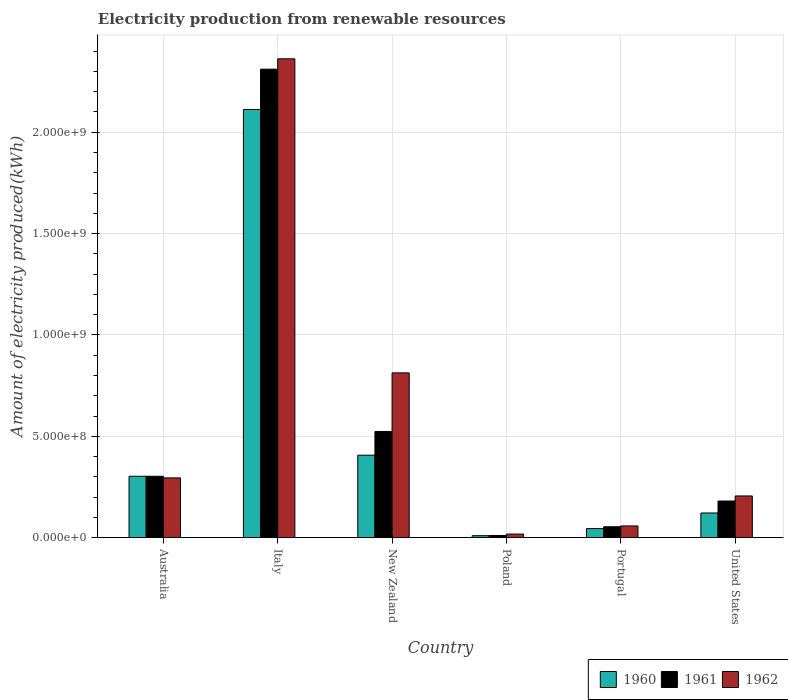How many different coloured bars are there?
Offer a terse response. 3. Are the number of bars on each tick of the X-axis equal?
Provide a succinct answer. Yes. How many bars are there on the 5th tick from the right?
Offer a very short reply. 3. What is the label of the 6th group of bars from the left?
Give a very brief answer. United States. In how many cases, is the number of bars for a given country not equal to the number of legend labels?
Ensure brevity in your answer.  0. What is the amount of electricity produced in 1960 in New Zealand?
Your answer should be very brief. 4.07e+08. Across all countries, what is the maximum amount of electricity produced in 1961?
Offer a very short reply. 2.31e+09. Across all countries, what is the minimum amount of electricity produced in 1962?
Keep it short and to the point. 1.80e+07. What is the total amount of electricity produced in 1962 in the graph?
Provide a short and direct response. 3.75e+09. What is the difference between the amount of electricity produced in 1962 in Italy and that in United States?
Ensure brevity in your answer.  2.16e+09. What is the difference between the amount of electricity produced in 1962 in Portugal and the amount of electricity produced in 1960 in Poland?
Your answer should be compact. 4.80e+07. What is the average amount of electricity produced in 1962 per country?
Provide a short and direct response. 6.25e+08. What is the difference between the amount of electricity produced of/in 1961 and amount of electricity produced of/in 1962 in New Zealand?
Offer a very short reply. -2.89e+08. What is the ratio of the amount of electricity produced in 1960 in Italy to that in Poland?
Provide a short and direct response. 211.2. Is the difference between the amount of electricity produced in 1961 in New Zealand and Portugal greater than the difference between the amount of electricity produced in 1962 in New Zealand and Portugal?
Ensure brevity in your answer.  No. What is the difference between the highest and the second highest amount of electricity produced in 1960?
Your answer should be very brief. 1.81e+09. What is the difference between the highest and the lowest amount of electricity produced in 1961?
Ensure brevity in your answer.  2.30e+09. In how many countries, is the amount of electricity produced in 1962 greater than the average amount of electricity produced in 1962 taken over all countries?
Keep it short and to the point. 2. Is the sum of the amount of electricity produced in 1962 in Australia and United States greater than the maximum amount of electricity produced in 1960 across all countries?
Provide a succinct answer. No. What does the 3rd bar from the left in United States represents?
Give a very brief answer. 1962. Are all the bars in the graph horizontal?
Your answer should be very brief. No. What is the difference between two consecutive major ticks on the Y-axis?
Your answer should be very brief. 5.00e+08. Are the values on the major ticks of Y-axis written in scientific E-notation?
Your answer should be compact. Yes. How many legend labels are there?
Your answer should be compact. 3. What is the title of the graph?
Give a very brief answer. Electricity production from renewable resources. What is the label or title of the X-axis?
Offer a very short reply. Country. What is the label or title of the Y-axis?
Keep it short and to the point. Amount of electricity produced(kWh). What is the Amount of electricity produced(kWh) of 1960 in Australia?
Your response must be concise. 3.03e+08. What is the Amount of electricity produced(kWh) in 1961 in Australia?
Give a very brief answer. 3.03e+08. What is the Amount of electricity produced(kWh) of 1962 in Australia?
Your answer should be very brief. 2.95e+08. What is the Amount of electricity produced(kWh) of 1960 in Italy?
Offer a terse response. 2.11e+09. What is the Amount of electricity produced(kWh) of 1961 in Italy?
Your answer should be compact. 2.31e+09. What is the Amount of electricity produced(kWh) of 1962 in Italy?
Your answer should be very brief. 2.36e+09. What is the Amount of electricity produced(kWh) of 1960 in New Zealand?
Your answer should be compact. 4.07e+08. What is the Amount of electricity produced(kWh) of 1961 in New Zealand?
Provide a succinct answer. 5.24e+08. What is the Amount of electricity produced(kWh) of 1962 in New Zealand?
Provide a succinct answer. 8.13e+08. What is the Amount of electricity produced(kWh) of 1961 in Poland?
Offer a very short reply. 1.10e+07. What is the Amount of electricity produced(kWh) in 1962 in Poland?
Give a very brief answer. 1.80e+07. What is the Amount of electricity produced(kWh) in 1960 in Portugal?
Make the answer very short. 4.50e+07. What is the Amount of electricity produced(kWh) of 1961 in Portugal?
Ensure brevity in your answer.  5.40e+07. What is the Amount of electricity produced(kWh) of 1962 in Portugal?
Keep it short and to the point. 5.80e+07. What is the Amount of electricity produced(kWh) of 1960 in United States?
Your answer should be very brief. 1.22e+08. What is the Amount of electricity produced(kWh) of 1961 in United States?
Ensure brevity in your answer.  1.81e+08. What is the Amount of electricity produced(kWh) of 1962 in United States?
Offer a very short reply. 2.06e+08. Across all countries, what is the maximum Amount of electricity produced(kWh) of 1960?
Ensure brevity in your answer.  2.11e+09. Across all countries, what is the maximum Amount of electricity produced(kWh) in 1961?
Make the answer very short. 2.31e+09. Across all countries, what is the maximum Amount of electricity produced(kWh) in 1962?
Offer a very short reply. 2.36e+09. Across all countries, what is the minimum Amount of electricity produced(kWh) in 1961?
Make the answer very short. 1.10e+07. Across all countries, what is the minimum Amount of electricity produced(kWh) in 1962?
Keep it short and to the point. 1.80e+07. What is the total Amount of electricity produced(kWh) of 1960 in the graph?
Offer a terse response. 3.00e+09. What is the total Amount of electricity produced(kWh) of 1961 in the graph?
Give a very brief answer. 3.38e+09. What is the total Amount of electricity produced(kWh) of 1962 in the graph?
Make the answer very short. 3.75e+09. What is the difference between the Amount of electricity produced(kWh) of 1960 in Australia and that in Italy?
Make the answer very short. -1.81e+09. What is the difference between the Amount of electricity produced(kWh) in 1961 in Australia and that in Italy?
Give a very brief answer. -2.01e+09. What is the difference between the Amount of electricity produced(kWh) of 1962 in Australia and that in Italy?
Make the answer very short. -2.07e+09. What is the difference between the Amount of electricity produced(kWh) in 1960 in Australia and that in New Zealand?
Make the answer very short. -1.04e+08. What is the difference between the Amount of electricity produced(kWh) in 1961 in Australia and that in New Zealand?
Keep it short and to the point. -2.21e+08. What is the difference between the Amount of electricity produced(kWh) of 1962 in Australia and that in New Zealand?
Your answer should be very brief. -5.18e+08. What is the difference between the Amount of electricity produced(kWh) in 1960 in Australia and that in Poland?
Offer a very short reply. 2.93e+08. What is the difference between the Amount of electricity produced(kWh) of 1961 in Australia and that in Poland?
Keep it short and to the point. 2.92e+08. What is the difference between the Amount of electricity produced(kWh) of 1962 in Australia and that in Poland?
Give a very brief answer. 2.77e+08. What is the difference between the Amount of electricity produced(kWh) in 1960 in Australia and that in Portugal?
Provide a short and direct response. 2.58e+08. What is the difference between the Amount of electricity produced(kWh) in 1961 in Australia and that in Portugal?
Your response must be concise. 2.49e+08. What is the difference between the Amount of electricity produced(kWh) in 1962 in Australia and that in Portugal?
Keep it short and to the point. 2.37e+08. What is the difference between the Amount of electricity produced(kWh) in 1960 in Australia and that in United States?
Give a very brief answer. 1.81e+08. What is the difference between the Amount of electricity produced(kWh) in 1961 in Australia and that in United States?
Offer a very short reply. 1.22e+08. What is the difference between the Amount of electricity produced(kWh) in 1962 in Australia and that in United States?
Ensure brevity in your answer.  8.90e+07. What is the difference between the Amount of electricity produced(kWh) in 1960 in Italy and that in New Zealand?
Offer a very short reply. 1.70e+09. What is the difference between the Amount of electricity produced(kWh) of 1961 in Italy and that in New Zealand?
Provide a short and direct response. 1.79e+09. What is the difference between the Amount of electricity produced(kWh) of 1962 in Italy and that in New Zealand?
Provide a succinct answer. 1.55e+09. What is the difference between the Amount of electricity produced(kWh) in 1960 in Italy and that in Poland?
Make the answer very short. 2.10e+09. What is the difference between the Amount of electricity produced(kWh) of 1961 in Italy and that in Poland?
Offer a terse response. 2.30e+09. What is the difference between the Amount of electricity produced(kWh) of 1962 in Italy and that in Poland?
Offer a terse response. 2.34e+09. What is the difference between the Amount of electricity produced(kWh) of 1960 in Italy and that in Portugal?
Offer a terse response. 2.07e+09. What is the difference between the Amount of electricity produced(kWh) of 1961 in Italy and that in Portugal?
Your answer should be compact. 2.26e+09. What is the difference between the Amount of electricity produced(kWh) of 1962 in Italy and that in Portugal?
Your response must be concise. 2.30e+09. What is the difference between the Amount of electricity produced(kWh) of 1960 in Italy and that in United States?
Keep it short and to the point. 1.99e+09. What is the difference between the Amount of electricity produced(kWh) in 1961 in Italy and that in United States?
Ensure brevity in your answer.  2.13e+09. What is the difference between the Amount of electricity produced(kWh) in 1962 in Italy and that in United States?
Your answer should be compact. 2.16e+09. What is the difference between the Amount of electricity produced(kWh) of 1960 in New Zealand and that in Poland?
Your answer should be very brief. 3.97e+08. What is the difference between the Amount of electricity produced(kWh) in 1961 in New Zealand and that in Poland?
Your response must be concise. 5.13e+08. What is the difference between the Amount of electricity produced(kWh) in 1962 in New Zealand and that in Poland?
Ensure brevity in your answer.  7.95e+08. What is the difference between the Amount of electricity produced(kWh) of 1960 in New Zealand and that in Portugal?
Offer a terse response. 3.62e+08. What is the difference between the Amount of electricity produced(kWh) of 1961 in New Zealand and that in Portugal?
Give a very brief answer. 4.70e+08. What is the difference between the Amount of electricity produced(kWh) of 1962 in New Zealand and that in Portugal?
Ensure brevity in your answer.  7.55e+08. What is the difference between the Amount of electricity produced(kWh) in 1960 in New Zealand and that in United States?
Provide a succinct answer. 2.85e+08. What is the difference between the Amount of electricity produced(kWh) of 1961 in New Zealand and that in United States?
Ensure brevity in your answer.  3.43e+08. What is the difference between the Amount of electricity produced(kWh) in 1962 in New Zealand and that in United States?
Offer a terse response. 6.07e+08. What is the difference between the Amount of electricity produced(kWh) in 1960 in Poland and that in Portugal?
Ensure brevity in your answer.  -3.50e+07. What is the difference between the Amount of electricity produced(kWh) in 1961 in Poland and that in Portugal?
Your response must be concise. -4.30e+07. What is the difference between the Amount of electricity produced(kWh) of 1962 in Poland and that in Portugal?
Offer a terse response. -4.00e+07. What is the difference between the Amount of electricity produced(kWh) of 1960 in Poland and that in United States?
Make the answer very short. -1.12e+08. What is the difference between the Amount of electricity produced(kWh) of 1961 in Poland and that in United States?
Give a very brief answer. -1.70e+08. What is the difference between the Amount of electricity produced(kWh) in 1962 in Poland and that in United States?
Make the answer very short. -1.88e+08. What is the difference between the Amount of electricity produced(kWh) of 1960 in Portugal and that in United States?
Your answer should be compact. -7.70e+07. What is the difference between the Amount of electricity produced(kWh) in 1961 in Portugal and that in United States?
Provide a succinct answer. -1.27e+08. What is the difference between the Amount of electricity produced(kWh) of 1962 in Portugal and that in United States?
Your response must be concise. -1.48e+08. What is the difference between the Amount of electricity produced(kWh) of 1960 in Australia and the Amount of electricity produced(kWh) of 1961 in Italy?
Keep it short and to the point. -2.01e+09. What is the difference between the Amount of electricity produced(kWh) of 1960 in Australia and the Amount of electricity produced(kWh) of 1962 in Italy?
Offer a terse response. -2.06e+09. What is the difference between the Amount of electricity produced(kWh) in 1961 in Australia and the Amount of electricity produced(kWh) in 1962 in Italy?
Ensure brevity in your answer.  -2.06e+09. What is the difference between the Amount of electricity produced(kWh) of 1960 in Australia and the Amount of electricity produced(kWh) of 1961 in New Zealand?
Give a very brief answer. -2.21e+08. What is the difference between the Amount of electricity produced(kWh) in 1960 in Australia and the Amount of electricity produced(kWh) in 1962 in New Zealand?
Keep it short and to the point. -5.10e+08. What is the difference between the Amount of electricity produced(kWh) in 1961 in Australia and the Amount of electricity produced(kWh) in 1962 in New Zealand?
Give a very brief answer. -5.10e+08. What is the difference between the Amount of electricity produced(kWh) of 1960 in Australia and the Amount of electricity produced(kWh) of 1961 in Poland?
Give a very brief answer. 2.92e+08. What is the difference between the Amount of electricity produced(kWh) of 1960 in Australia and the Amount of electricity produced(kWh) of 1962 in Poland?
Provide a succinct answer. 2.85e+08. What is the difference between the Amount of electricity produced(kWh) in 1961 in Australia and the Amount of electricity produced(kWh) in 1962 in Poland?
Give a very brief answer. 2.85e+08. What is the difference between the Amount of electricity produced(kWh) in 1960 in Australia and the Amount of electricity produced(kWh) in 1961 in Portugal?
Your response must be concise. 2.49e+08. What is the difference between the Amount of electricity produced(kWh) of 1960 in Australia and the Amount of electricity produced(kWh) of 1962 in Portugal?
Give a very brief answer. 2.45e+08. What is the difference between the Amount of electricity produced(kWh) in 1961 in Australia and the Amount of electricity produced(kWh) in 1962 in Portugal?
Your answer should be compact. 2.45e+08. What is the difference between the Amount of electricity produced(kWh) in 1960 in Australia and the Amount of electricity produced(kWh) in 1961 in United States?
Your answer should be compact. 1.22e+08. What is the difference between the Amount of electricity produced(kWh) of 1960 in Australia and the Amount of electricity produced(kWh) of 1962 in United States?
Make the answer very short. 9.70e+07. What is the difference between the Amount of electricity produced(kWh) of 1961 in Australia and the Amount of electricity produced(kWh) of 1962 in United States?
Offer a very short reply. 9.70e+07. What is the difference between the Amount of electricity produced(kWh) of 1960 in Italy and the Amount of electricity produced(kWh) of 1961 in New Zealand?
Provide a succinct answer. 1.59e+09. What is the difference between the Amount of electricity produced(kWh) in 1960 in Italy and the Amount of electricity produced(kWh) in 1962 in New Zealand?
Make the answer very short. 1.30e+09. What is the difference between the Amount of electricity produced(kWh) in 1961 in Italy and the Amount of electricity produced(kWh) in 1962 in New Zealand?
Provide a short and direct response. 1.50e+09. What is the difference between the Amount of electricity produced(kWh) of 1960 in Italy and the Amount of electricity produced(kWh) of 1961 in Poland?
Offer a very short reply. 2.10e+09. What is the difference between the Amount of electricity produced(kWh) in 1960 in Italy and the Amount of electricity produced(kWh) in 1962 in Poland?
Provide a succinct answer. 2.09e+09. What is the difference between the Amount of electricity produced(kWh) in 1961 in Italy and the Amount of electricity produced(kWh) in 1962 in Poland?
Provide a short and direct response. 2.29e+09. What is the difference between the Amount of electricity produced(kWh) in 1960 in Italy and the Amount of electricity produced(kWh) in 1961 in Portugal?
Make the answer very short. 2.06e+09. What is the difference between the Amount of electricity produced(kWh) in 1960 in Italy and the Amount of electricity produced(kWh) in 1962 in Portugal?
Your response must be concise. 2.05e+09. What is the difference between the Amount of electricity produced(kWh) of 1961 in Italy and the Amount of electricity produced(kWh) of 1962 in Portugal?
Your answer should be very brief. 2.25e+09. What is the difference between the Amount of electricity produced(kWh) in 1960 in Italy and the Amount of electricity produced(kWh) in 1961 in United States?
Your response must be concise. 1.93e+09. What is the difference between the Amount of electricity produced(kWh) of 1960 in Italy and the Amount of electricity produced(kWh) of 1962 in United States?
Provide a short and direct response. 1.91e+09. What is the difference between the Amount of electricity produced(kWh) of 1961 in Italy and the Amount of electricity produced(kWh) of 1962 in United States?
Keep it short and to the point. 2.10e+09. What is the difference between the Amount of electricity produced(kWh) of 1960 in New Zealand and the Amount of electricity produced(kWh) of 1961 in Poland?
Keep it short and to the point. 3.96e+08. What is the difference between the Amount of electricity produced(kWh) in 1960 in New Zealand and the Amount of electricity produced(kWh) in 1962 in Poland?
Your answer should be compact. 3.89e+08. What is the difference between the Amount of electricity produced(kWh) in 1961 in New Zealand and the Amount of electricity produced(kWh) in 1962 in Poland?
Provide a succinct answer. 5.06e+08. What is the difference between the Amount of electricity produced(kWh) of 1960 in New Zealand and the Amount of electricity produced(kWh) of 1961 in Portugal?
Offer a terse response. 3.53e+08. What is the difference between the Amount of electricity produced(kWh) in 1960 in New Zealand and the Amount of electricity produced(kWh) in 1962 in Portugal?
Provide a short and direct response. 3.49e+08. What is the difference between the Amount of electricity produced(kWh) in 1961 in New Zealand and the Amount of electricity produced(kWh) in 1962 in Portugal?
Your answer should be very brief. 4.66e+08. What is the difference between the Amount of electricity produced(kWh) in 1960 in New Zealand and the Amount of electricity produced(kWh) in 1961 in United States?
Ensure brevity in your answer.  2.26e+08. What is the difference between the Amount of electricity produced(kWh) of 1960 in New Zealand and the Amount of electricity produced(kWh) of 1962 in United States?
Provide a short and direct response. 2.01e+08. What is the difference between the Amount of electricity produced(kWh) of 1961 in New Zealand and the Amount of electricity produced(kWh) of 1962 in United States?
Offer a terse response. 3.18e+08. What is the difference between the Amount of electricity produced(kWh) of 1960 in Poland and the Amount of electricity produced(kWh) of 1961 in Portugal?
Make the answer very short. -4.40e+07. What is the difference between the Amount of electricity produced(kWh) of 1960 in Poland and the Amount of electricity produced(kWh) of 1962 in Portugal?
Provide a short and direct response. -4.80e+07. What is the difference between the Amount of electricity produced(kWh) of 1961 in Poland and the Amount of electricity produced(kWh) of 1962 in Portugal?
Your answer should be very brief. -4.70e+07. What is the difference between the Amount of electricity produced(kWh) in 1960 in Poland and the Amount of electricity produced(kWh) in 1961 in United States?
Provide a short and direct response. -1.71e+08. What is the difference between the Amount of electricity produced(kWh) in 1960 in Poland and the Amount of electricity produced(kWh) in 1962 in United States?
Offer a terse response. -1.96e+08. What is the difference between the Amount of electricity produced(kWh) in 1961 in Poland and the Amount of electricity produced(kWh) in 1962 in United States?
Offer a very short reply. -1.95e+08. What is the difference between the Amount of electricity produced(kWh) of 1960 in Portugal and the Amount of electricity produced(kWh) of 1961 in United States?
Your response must be concise. -1.36e+08. What is the difference between the Amount of electricity produced(kWh) in 1960 in Portugal and the Amount of electricity produced(kWh) in 1962 in United States?
Offer a terse response. -1.61e+08. What is the difference between the Amount of electricity produced(kWh) of 1961 in Portugal and the Amount of electricity produced(kWh) of 1962 in United States?
Offer a terse response. -1.52e+08. What is the average Amount of electricity produced(kWh) in 1960 per country?
Your answer should be very brief. 5.00e+08. What is the average Amount of electricity produced(kWh) in 1961 per country?
Keep it short and to the point. 5.64e+08. What is the average Amount of electricity produced(kWh) in 1962 per country?
Offer a terse response. 6.25e+08. What is the difference between the Amount of electricity produced(kWh) of 1960 and Amount of electricity produced(kWh) of 1961 in Australia?
Offer a terse response. 0. What is the difference between the Amount of electricity produced(kWh) in 1960 and Amount of electricity produced(kWh) in 1962 in Australia?
Keep it short and to the point. 8.00e+06. What is the difference between the Amount of electricity produced(kWh) in 1961 and Amount of electricity produced(kWh) in 1962 in Australia?
Your answer should be very brief. 8.00e+06. What is the difference between the Amount of electricity produced(kWh) in 1960 and Amount of electricity produced(kWh) in 1961 in Italy?
Offer a terse response. -1.99e+08. What is the difference between the Amount of electricity produced(kWh) of 1960 and Amount of electricity produced(kWh) of 1962 in Italy?
Ensure brevity in your answer.  -2.50e+08. What is the difference between the Amount of electricity produced(kWh) in 1961 and Amount of electricity produced(kWh) in 1962 in Italy?
Your answer should be very brief. -5.10e+07. What is the difference between the Amount of electricity produced(kWh) of 1960 and Amount of electricity produced(kWh) of 1961 in New Zealand?
Provide a short and direct response. -1.17e+08. What is the difference between the Amount of electricity produced(kWh) in 1960 and Amount of electricity produced(kWh) in 1962 in New Zealand?
Give a very brief answer. -4.06e+08. What is the difference between the Amount of electricity produced(kWh) in 1961 and Amount of electricity produced(kWh) in 1962 in New Zealand?
Offer a terse response. -2.89e+08. What is the difference between the Amount of electricity produced(kWh) in 1960 and Amount of electricity produced(kWh) in 1961 in Poland?
Ensure brevity in your answer.  -1.00e+06. What is the difference between the Amount of electricity produced(kWh) in 1960 and Amount of electricity produced(kWh) in 1962 in Poland?
Provide a short and direct response. -8.00e+06. What is the difference between the Amount of electricity produced(kWh) in 1961 and Amount of electricity produced(kWh) in 1962 in Poland?
Your answer should be very brief. -7.00e+06. What is the difference between the Amount of electricity produced(kWh) in 1960 and Amount of electricity produced(kWh) in 1961 in Portugal?
Keep it short and to the point. -9.00e+06. What is the difference between the Amount of electricity produced(kWh) in 1960 and Amount of electricity produced(kWh) in 1962 in Portugal?
Make the answer very short. -1.30e+07. What is the difference between the Amount of electricity produced(kWh) in 1960 and Amount of electricity produced(kWh) in 1961 in United States?
Ensure brevity in your answer.  -5.90e+07. What is the difference between the Amount of electricity produced(kWh) in 1960 and Amount of electricity produced(kWh) in 1962 in United States?
Make the answer very short. -8.40e+07. What is the difference between the Amount of electricity produced(kWh) in 1961 and Amount of electricity produced(kWh) in 1962 in United States?
Your answer should be compact. -2.50e+07. What is the ratio of the Amount of electricity produced(kWh) of 1960 in Australia to that in Italy?
Offer a very short reply. 0.14. What is the ratio of the Amount of electricity produced(kWh) in 1961 in Australia to that in Italy?
Ensure brevity in your answer.  0.13. What is the ratio of the Amount of electricity produced(kWh) of 1962 in Australia to that in Italy?
Keep it short and to the point. 0.12. What is the ratio of the Amount of electricity produced(kWh) of 1960 in Australia to that in New Zealand?
Your response must be concise. 0.74. What is the ratio of the Amount of electricity produced(kWh) of 1961 in Australia to that in New Zealand?
Provide a short and direct response. 0.58. What is the ratio of the Amount of electricity produced(kWh) of 1962 in Australia to that in New Zealand?
Your answer should be compact. 0.36. What is the ratio of the Amount of electricity produced(kWh) in 1960 in Australia to that in Poland?
Your answer should be very brief. 30.3. What is the ratio of the Amount of electricity produced(kWh) in 1961 in Australia to that in Poland?
Ensure brevity in your answer.  27.55. What is the ratio of the Amount of electricity produced(kWh) in 1962 in Australia to that in Poland?
Make the answer very short. 16.39. What is the ratio of the Amount of electricity produced(kWh) in 1960 in Australia to that in Portugal?
Make the answer very short. 6.73. What is the ratio of the Amount of electricity produced(kWh) of 1961 in Australia to that in Portugal?
Your answer should be very brief. 5.61. What is the ratio of the Amount of electricity produced(kWh) in 1962 in Australia to that in Portugal?
Keep it short and to the point. 5.09. What is the ratio of the Amount of electricity produced(kWh) in 1960 in Australia to that in United States?
Offer a very short reply. 2.48. What is the ratio of the Amount of electricity produced(kWh) in 1961 in Australia to that in United States?
Your response must be concise. 1.67. What is the ratio of the Amount of electricity produced(kWh) of 1962 in Australia to that in United States?
Make the answer very short. 1.43. What is the ratio of the Amount of electricity produced(kWh) in 1960 in Italy to that in New Zealand?
Your response must be concise. 5.19. What is the ratio of the Amount of electricity produced(kWh) in 1961 in Italy to that in New Zealand?
Your response must be concise. 4.41. What is the ratio of the Amount of electricity produced(kWh) in 1962 in Italy to that in New Zealand?
Your answer should be compact. 2.91. What is the ratio of the Amount of electricity produced(kWh) of 1960 in Italy to that in Poland?
Your answer should be very brief. 211.2. What is the ratio of the Amount of electricity produced(kWh) in 1961 in Italy to that in Poland?
Your answer should be compact. 210.09. What is the ratio of the Amount of electricity produced(kWh) in 1962 in Italy to that in Poland?
Ensure brevity in your answer.  131.22. What is the ratio of the Amount of electricity produced(kWh) of 1960 in Italy to that in Portugal?
Provide a short and direct response. 46.93. What is the ratio of the Amount of electricity produced(kWh) of 1961 in Italy to that in Portugal?
Offer a terse response. 42.8. What is the ratio of the Amount of electricity produced(kWh) of 1962 in Italy to that in Portugal?
Make the answer very short. 40.72. What is the ratio of the Amount of electricity produced(kWh) in 1960 in Italy to that in United States?
Provide a short and direct response. 17.31. What is the ratio of the Amount of electricity produced(kWh) of 1961 in Italy to that in United States?
Your answer should be very brief. 12.77. What is the ratio of the Amount of electricity produced(kWh) of 1962 in Italy to that in United States?
Offer a very short reply. 11.47. What is the ratio of the Amount of electricity produced(kWh) of 1960 in New Zealand to that in Poland?
Your answer should be compact. 40.7. What is the ratio of the Amount of electricity produced(kWh) in 1961 in New Zealand to that in Poland?
Offer a very short reply. 47.64. What is the ratio of the Amount of electricity produced(kWh) of 1962 in New Zealand to that in Poland?
Your answer should be very brief. 45.17. What is the ratio of the Amount of electricity produced(kWh) in 1960 in New Zealand to that in Portugal?
Give a very brief answer. 9.04. What is the ratio of the Amount of electricity produced(kWh) in 1961 in New Zealand to that in Portugal?
Make the answer very short. 9.7. What is the ratio of the Amount of electricity produced(kWh) of 1962 in New Zealand to that in Portugal?
Provide a succinct answer. 14.02. What is the ratio of the Amount of electricity produced(kWh) of 1960 in New Zealand to that in United States?
Offer a very short reply. 3.34. What is the ratio of the Amount of electricity produced(kWh) of 1961 in New Zealand to that in United States?
Your response must be concise. 2.9. What is the ratio of the Amount of electricity produced(kWh) of 1962 in New Zealand to that in United States?
Offer a terse response. 3.95. What is the ratio of the Amount of electricity produced(kWh) in 1960 in Poland to that in Portugal?
Keep it short and to the point. 0.22. What is the ratio of the Amount of electricity produced(kWh) of 1961 in Poland to that in Portugal?
Your answer should be very brief. 0.2. What is the ratio of the Amount of electricity produced(kWh) in 1962 in Poland to that in Portugal?
Provide a short and direct response. 0.31. What is the ratio of the Amount of electricity produced(kWh) in 1960 in Poland to that in United States?
Your response must be concise. 0.08. What is the ratio of the Amount of electricity produced(kWh) of 1961 in Poland to that in United States?
Offer a terse response. 0.06. What is the ratio of the Amount of electricity produced(kWh) in 1962 in Poland to that in United States?
Keep it short and to the point. 0.09. What is the ratio of the Amount of electricity produced(kWh) of 1960 in Portugal to that in United States?
Your answer should be compact. 0.37. What is the ratio of the Amount of electricity produced(kWh) in 1961 in Portugal to that in United States?
Your answer should be very brief. 0.3. What is the ratio of the Amount of electricity produced(kWh) of 1962 in Portugal to that in United States?
Give a very brief answer. 0.28. What is the difference between the highest and the second highest Amount of electricity produced(kWh) of 1960?
Ensure brevity in your answer.  1.70e+09. What is the difference between the highest and the second highest Amount of electricity produced(kWh) of 1961?
Provide a short and direct response. 1.79e+09. What is the difference between the highest and the second highest Amount of electricity produced(kWh) in 1962?
Ensure brevity in your answer.  1.55e+09. What is the difference between the highest and the lowest Amount of electricity produced(kWh) of 1960?
Provide a succinct answer. 2.10e+09. What is the difference between the highest and the lowest Amount of electricity produced(kWh) of 1961?
Give a very brief answer. 2.30e+09. What is the difference between the highest and the lowest Amount of electricity produced(kWh) of 1962?
Your answer should be very brief. 2.34e+09. 